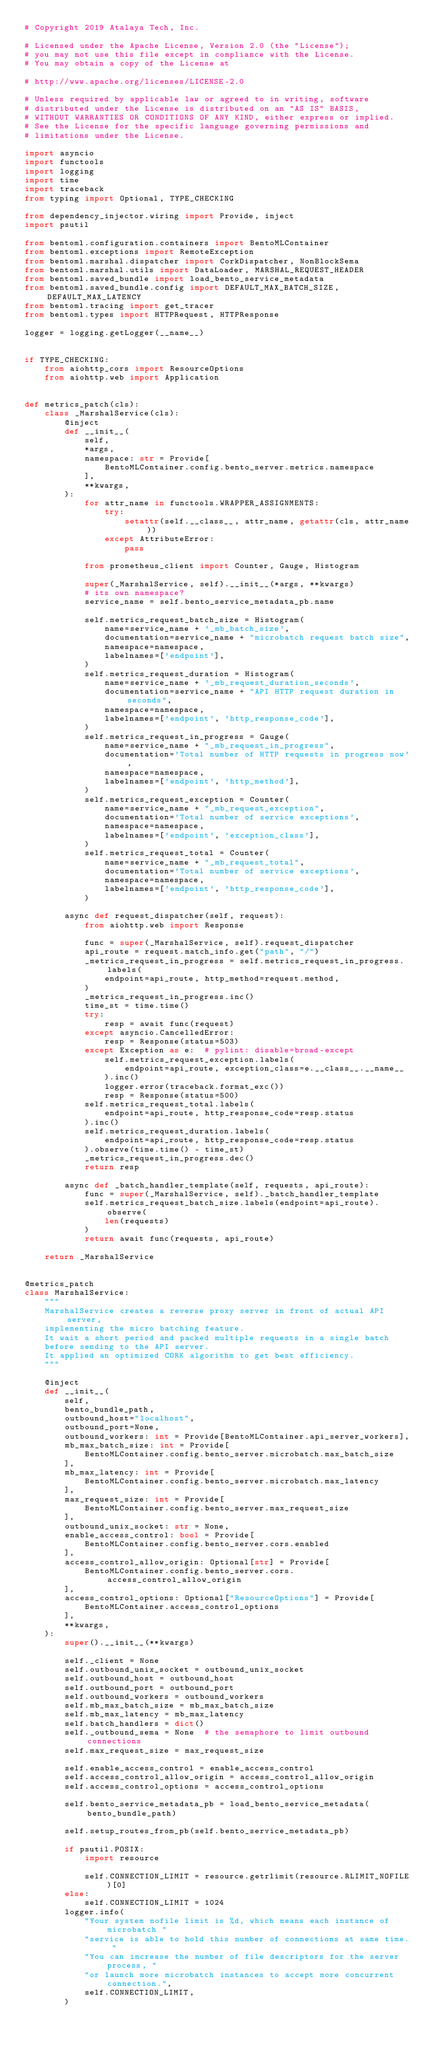<code> <loc_0><loc_0><loc_500><loc_500><_Python_># Copyright 2019 Atalaya Tech, Inc.

# Licensed under the Apache License, Version 2.0 (the "License");
# you may not use this file except in compliance with the License.
# You may obtain a copy of the License at

# http://www.apache.org/licenses/LICENSE-2.0

# Unless required by applicable law or agreed to in writing, software
# distributed under the License is distributed on an "AS IS" BASIS,
# WITHOUT WARRANTIES OR CONDITIONS OF ANY KIND, either express or implied.
# See the License for the specific language governing permissions and
# limitations under the License.

import asyncio
import functools
import logging
import time
import traceback
from typing import Optional, TYPE_CHECKING

from dependency_injector.wiring import Provide, inject
import psutil

from bentoml.configuration.containers import BentoMLContainer
from bentoml.exceptions import RemoteException
from bentoml.marshal.dispatcher import CorkDispatcher, NonBlockSema
from bentoml.marshal.utils import DataLoader, MARSHAL_REQUEST_HEADER
from bentoml.saved_bundle import load_bento_service_metadata
from bentoml.saved_bundle.config import DEFAULT_MAX_BATCH_SIZE, DEFAULT_MAX_LATENCY
from bentoml.tracing import get_tracer
from bentoml.types import HTTPRequest, HTTPResponse

logger = logging.getLogger(__name__)


if TYPE_CHECKING:
    from aiohttp_cors import ResourceOptions
    from aiohttp.web import Application


def metrics_patch(cls):
    class _MarshalService(cls):
        @inject
        def __init__(
            self,
            *args,
            namespace: str = Provide[
                BentoMLContainer.config.bento_server.metrics.namespace
            ],
            **kwargs,
        ):
            for attr_name in functools.WRAPPER_ASSIGNMENTS:
                try:
                    setattr(self.__class__, attr_name, getattr(cls, attr_name))
                except AttributeError:
                    pass

            from prometheus_client import Counter, Gauge, Histogram

            super(_MarshalService, self).__init__(*args, **kwargs)
            # its own namespace?
            service_name = self.bento_service_metadata_pb.name

            self.metrics_request_batch_size = Histogram(
                name=service_name + '_mb_batch_size',
                documentation=service_name + "microbatch request batch size",
                namespace=namespace,
                labelnames=['endpoint'],
            )
            self.metrics_request_duration = Histogram(
                name=service_name + '_mb_request_duration_seconds',
                documentation=service_name + "API HTTP request duration in seconds",
                namespace=namespace,
                labelnames=['endpoint', 'http_response_code'],
            )
            self.metrics_request_in_progress = Gauge(
                name=service_name + "_mb_request_in_progress",
                documentation='Total number of HTTP requests in progress now',
                namespace=namespace,
                labelnames=['endpoint', 'http_method'],
            )
            self.metrics_request_exception = Counter(
                name=service_name + "_mb_request_exception",
                documentation='Total number of service exceptions',
                namespace=namespace,
                labelnames=['endpoint', 'exception_class'],
            )
            self.metrics_request_total = Counter(
                name=service_name + "_mb_request_total",
                documentation='Total number of service exceptions',
                namespace=namespace,
                labelnames=['endpoint', 'http_response_code'],
            )

        async def request_dispatcher(self, request):
            from aiohttp.web import Response

            func = super(_MarshalService, self).request_dispatcher
            api_route = request.match_info.get("path", "/")
            _metrics_request_in_progress = self.metrics_request_in_progress.labels(
                endpoint=api_route, http_method=request.method,
            )
            _metrics_request_in_progress.inc()
            time_st = time.time()
            try:
                resp = await func(request)
            except asyncio.CancelledError:
                resp = Response(status=503)
            except Exception as e:  # pylint: disable=broad-except
                self.metrics_request_exception.labels(
                    endpoint=api_route, exception_class=e.__class__.__name__
                ).inc()
                logger.error(traceback.format_exc())
                resp = Response(status=500)
            self.metrics_request_total.labels(
                endpoint=api_route, http_response_code=resp.status
            ).inc()
            self.metrics_request_duration.labels(
                endpoint=api_route, http_response_code=resp.status
            ).observe(time.time() - time_st)
            _metrics_request_in_progress.dec()
            return resp

        async def _batch_handler_template(self, requests, api_route):
            func = super(_MarshalService, self)._batch_handler_template
            self.metrics_request_batch_size.labels(endpoint=api_route).observe(
                len(requests)
            )
            return await func(requests, api_route)

    return _MarshalService


@metrics_patch
class MarshalService:
    """
    MarshalService creates a reverse proxy server in front of actual API server,
    implementing the micro batching feature.
    It wait a short period and packed multiple requests in a single batch
    before sending to the API server.
    It applied an optimized CORK algorithm to get best efficiency.
    """

    @inject
    def __init__(
        self,
        bento_bundle_path,
        outbound_host="localhost",
        outbound_port=None,
        outbound_workers: int = Provide[BentoMLContainer.api_server_workers],
        mb_max_batch_size: int = Provide[
            BentoMLContainer.config.bento_server.microbatch.max_batch_size
        ],
        mb_max_latency: int = Provide[
            BentoMLContainer.config.bento_server.microbatch.max_latency
        ],
        max_request_size: int = Provide[
            BentoMLContainer.config.bento_server.max_request_size
        ],
        outbound_unix_socket: str = None,
        enable_access_control: bool = Provide[
            BentoMLContainer.config.bento_server.cors.enabled
        ],
        access_control_allow_origin: Optional[str] = Provide[
            BentoMLContainer.config.bento_server.cors.access_control_allow_origin
        ],
        access_control_options: Optional["ResourceOptions"] = Provide[
            BentoMLContainer.access_control_options
        ],
        **kwargs,
    ):
        super().__init__(**kwargs)

        self._client = None
        self.outbound_unix_socket = outbound_unix_socket
        self.outbound_host = outbound_host
        self.outbound_port = outbound_port
        self.outbound_workers = outbound_workers
        self.mb_max_batch_size = mb_max_batch_size
        self.mb_max_latency = mb_max_latency
        self.batch_handlers = dict()
        self._outbound_sema = None  # the semaphore to limit outbound connections
        self.max_request_size = max_request_size

        self.enable_access_control = enable_access_control
        self.access_control_allow_origin = access_control_allow_origin
        self.access_control_options = access_control_options

        self.bento_service_metadata_pb = load_bento_service_metadata(bento_bundle_path)

        self.setup_routes_from_pb(self.bento_service_metadata_pb)

        if psutil.POSIX:
            import resource

            self.CONNECTION_LIMIT = resource.getrlimit(resource.RLIMIT_NOFILE)[0]
        else:
            self.CONNECTION_LIMIT = 1024
        logger.info(
            "Your system nofile limit is %d, which means each instance of microbatch "
            "service is able to hold this number of connections at same time. "
            "You can increase the number of file descriptors for the server process, "
            "or launch more microbatch instances to accept more concurrent connection.",
            self.CONNECTION_LIMIT,
        )
</code> 